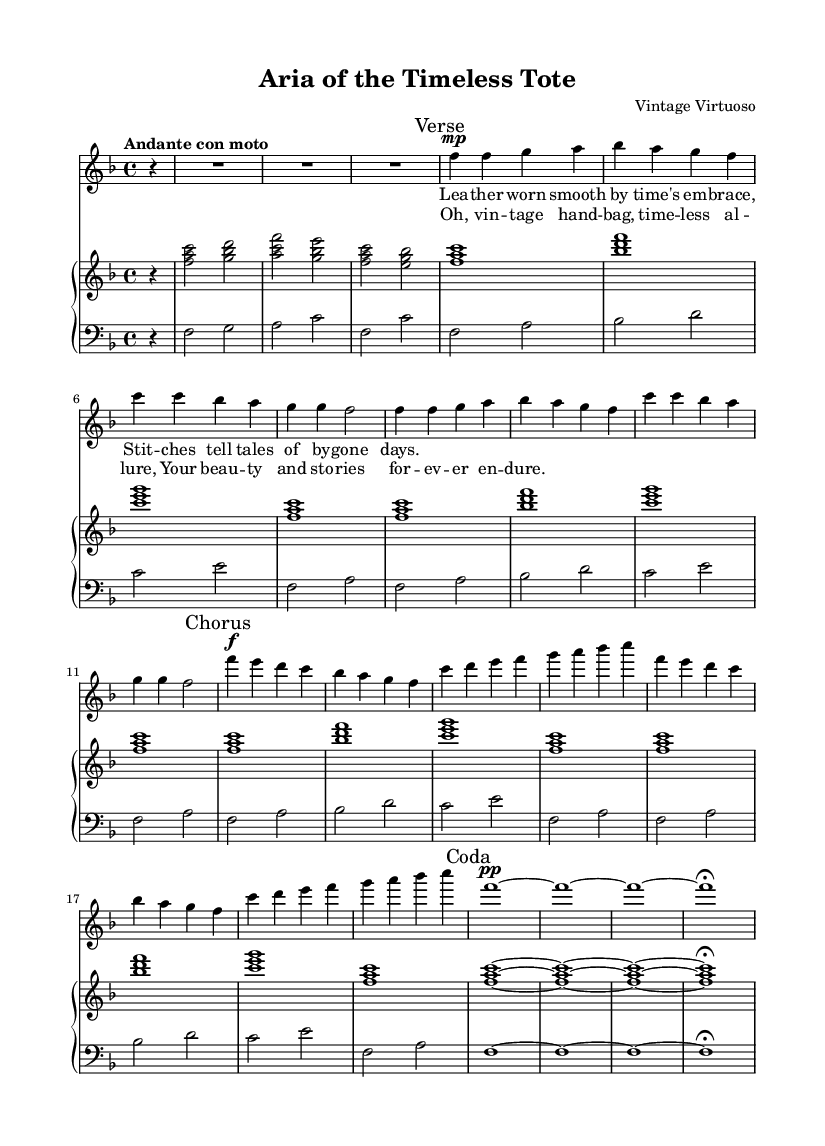what is the key signature of this music? The key signature is F major, which has one flat (B flat). This can be determined from the beginning of the piece, where the key signature clef is indicated.
Answer: F major what is the time signature of this music? The time signature is 4/4, which is indicated at the beginning of the score. This means there are four beats in each measure, and the quarter note gets one beat.
Answer: 4/4 what is the tempo marking of this piece? The tempo marking is "Andante con moto," which suggests a moderately slow pace with some movement. This is usually indicated in the tempo section at the start of the piece.
Answer: Andante con moto how many measures does the verse section contain? The verse section contains eight measures. This can be counted by looking at the measure lines within the verse portion of the sheet music.
Answer: eight what dynamic marking is given at the beginning of the chorus? The dynamic marking at the beginning of the chorus is forte (f), indicating a loud volume. This is shown at the start of the chorus section within the music.
Answer: forte how does the lyrical theme relate to the music structure? The lyrical theme highlights the beauty and stories associated with vintage handbags, which is mirrored in the romantic and expressive nature of the music, especially in its melodic phrases that evoke feelings of nostalgia and allure. This reasoning involves analyzing both the lyrics and the expressive qualities found in the music.
Answer: nostalgia and allure what is the role of the piano in this aria? The piano serves as both an accompaniment and a harmonic foundation for the soprano voice, enriching the overall sound and supporting the lyrical content. It complements the vocal line through chords and harmonic progressions, enhancing the emotional depth of the aria.
Answer: accompaniment 